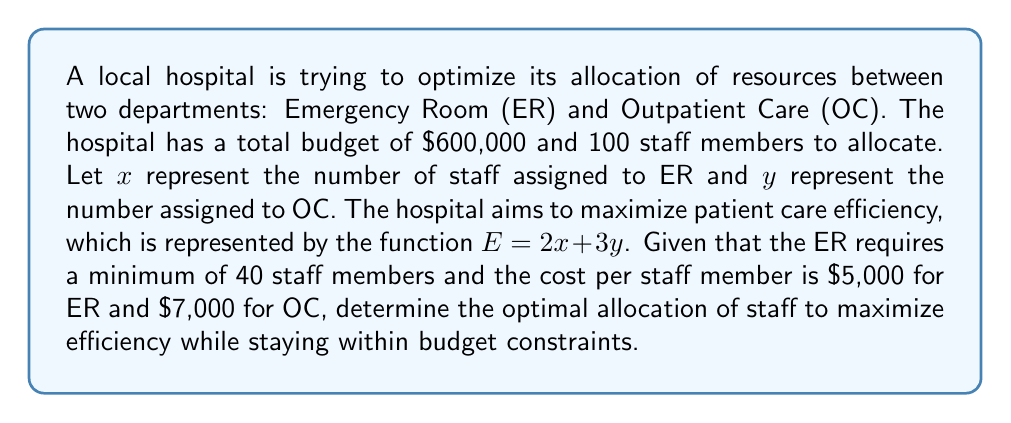Can you answer this question? Let's approach this step-by-step:

1) First, we need to set up our system of equations based on the given constraints:

   a) Total staff constraint: $x + y = 100$
   b) Budget constraint: $5000x + 7000y \leq 600000$
   c) ER minimum staff requirement: $x \geq 40$

2) Our objective is to maximize $E = 2x + 3y$

3) We can rewrite the budget constraint as an equation:
   $5000x + 7000y = 600000$ (we use equality because we want to use all available budget)

4) Now we have a system of two equations:
   $$\begin{cases}
   x + y = 100 \\
   5x + 7y = 600
   \end{cases}$$

5) We can solve this system by substitution. From the first equation:
   $y = 100 - x$

6) Substituting this into the second equation:
   $5x + 7(100 - x) = 600$
   $5x + 700 - 7x = 600$
   $-2x = -100$
   $x = 50$

7) Substituting back:
   $y = 100 - 50 = 50$

8) We need to check if this solution satisfies the ER minimum staff requirement:
   $x = 50 \geq 40$, so it does.

9) Finally, we calculate the efficiency:
   $E = 2x + 3y = 2(50) + 3(50) = 100 + 150 = 250$

Therefore, the optimal allocation is 50 staff members to ER and 50 to OC.
Answer: ER: 50 staff, OC: 50 staff, Maximum efficiency: 250 